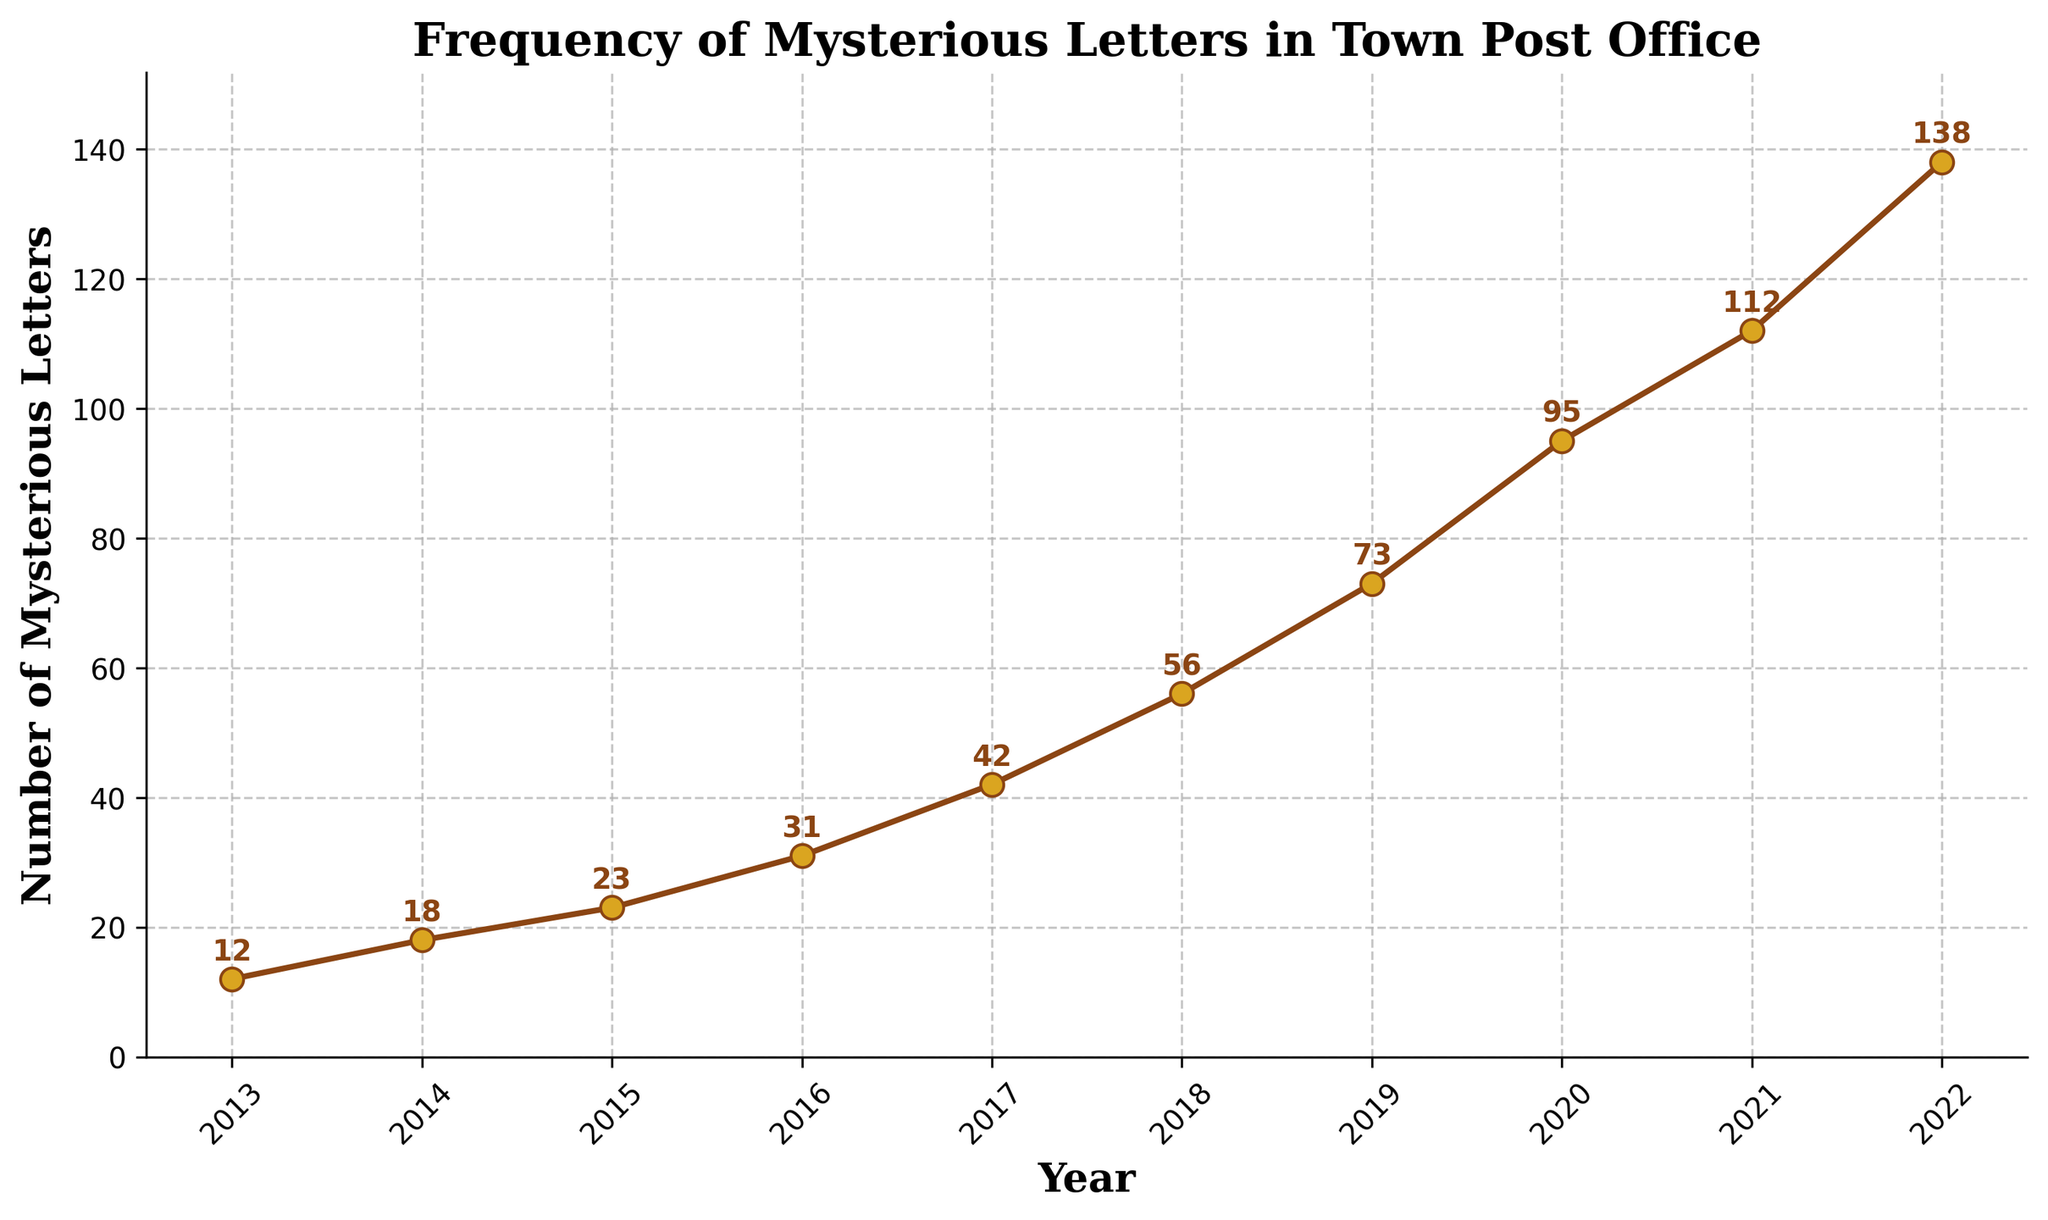What's the average number of mysterious letters received per year from 2013 to 2015? First, sum the numbers of mysterious letters received from 2013 to 2015: 12 + 18 + 23 = 53. Then, divide by the number of years (3): 53 / 3 ≈ 17.67
Answer: 17.67 Which year saw the highest number of mysterious letters received? By looking at the plot, the year 2022 had the highest number of mysterious letters at 138.
Answer: 2022 Between which two consecutive years did the number of mysterious letters increase the most? Calculate the differences between each pair of consecutive years: (2014-2013: 18-12=6), (2015-2014: 23-18=5), (2016-2015: 31-23=8), (2017-2016: 42-31=11), (2018-2017: 56-42=14), (2019-2018: 73-56=17), (2020-2019: 95-73=22), (2021-2020: 112-95=17), (2022-2021: 138-112=26). The largest increase is from 2021 to 2022.
Answer: 2021 to 2022 What is the total number of mysterious letters received over the entire decade? Sum all the numbers from 2013 to 2022: 12 + 18 + 23 + 31 + 42 + 56 + 73 + 95 + 112 + 138 = 600.
Answer: 600 How much did the number of mysterious letters received in 2022 exceed those received in 2013? Subtract the number of letters in 2013 from the number in 2022: 138 - 12 = 126.
Answer: 126 What is the general trend observed in the number of mysterious letters received over the years on the line chart? Observing the line chart, the number of mysterious letters received increases steadily each year, showing a general upward trend.
Answer: Upward trend Which year had nearly double the number of mysterious letters compared to the previous year? Comparing the values each year, 2020 saw 95 letters, nearly double from 2019's 73 (since 73 * 2 = 146 and 95 is close to half of 146).
Answer: 2020 If the trend continues, how many mysterious letters might you expect in 2023? Observing the increasing pattern, one might project another increment of about 26 letters (based on the previous maximum increase). So, 138 + 26 = 164.
Answer: 164 